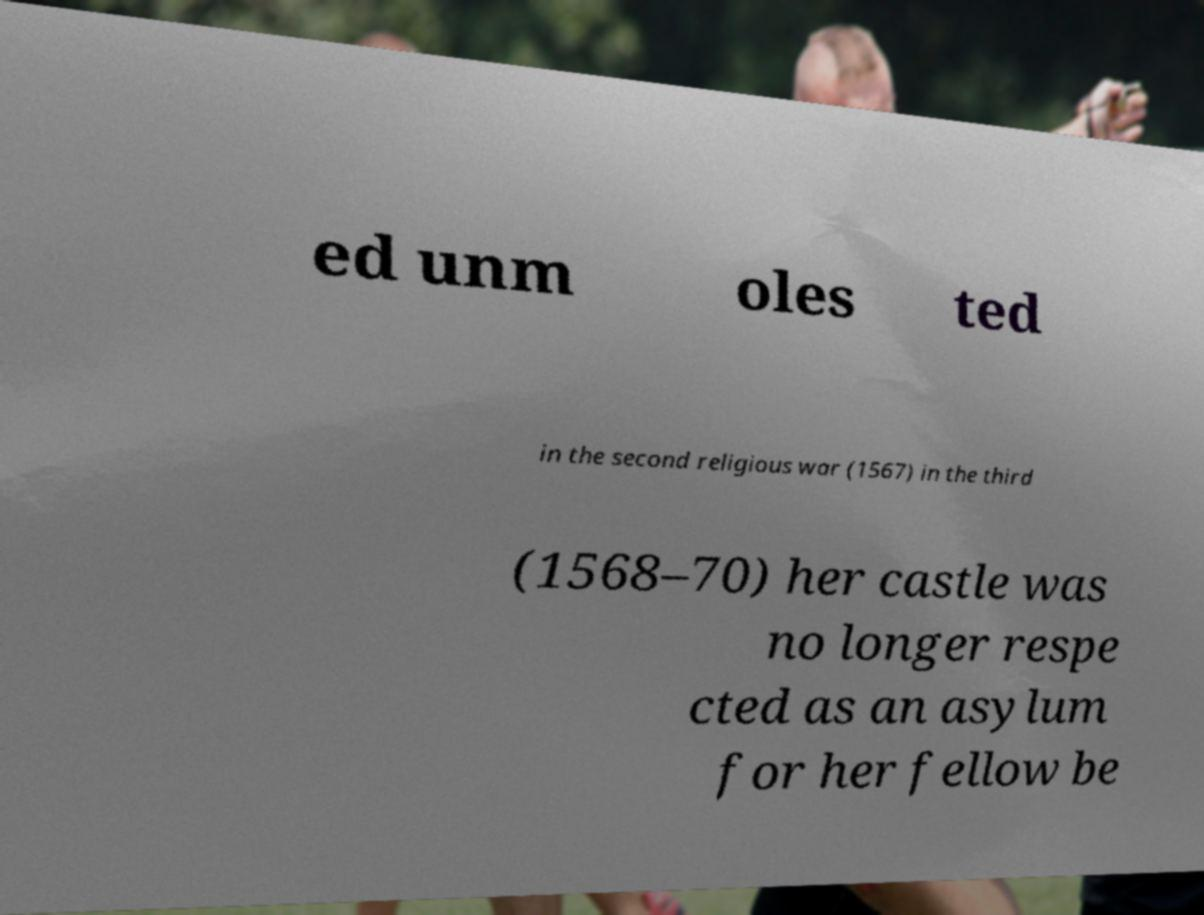I need the written content from this picture converted into text. Can you do that? ed unm oles ted in the second religious war (1567) in the third (1568–70) her castle was no longer respe cted as an asylum for her fellow be 